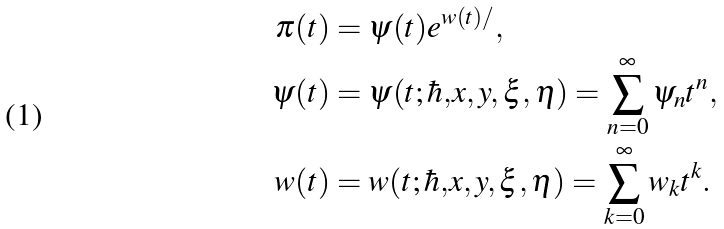Convert formula to latex. <formula><loc_0><loc_0><loc_500><loc_500>\pi ( t ) & = \psi ( t ) e ^ { w ( t ) / } , \\ \psi ( t ) & = \psi ( t ; \hbar { , } x , y , \xi , \eta ) = \sum _ { n = 0 } ^ { \infty } \psi _ { n } t ^ { n } , \\ w ( t ) & = w ( t ; \hbar { , } x , y , \xi , \eta ) = \sum _ { k = 0 } ^ { \infty } w _ { k } t ^ { k } .</formula> 